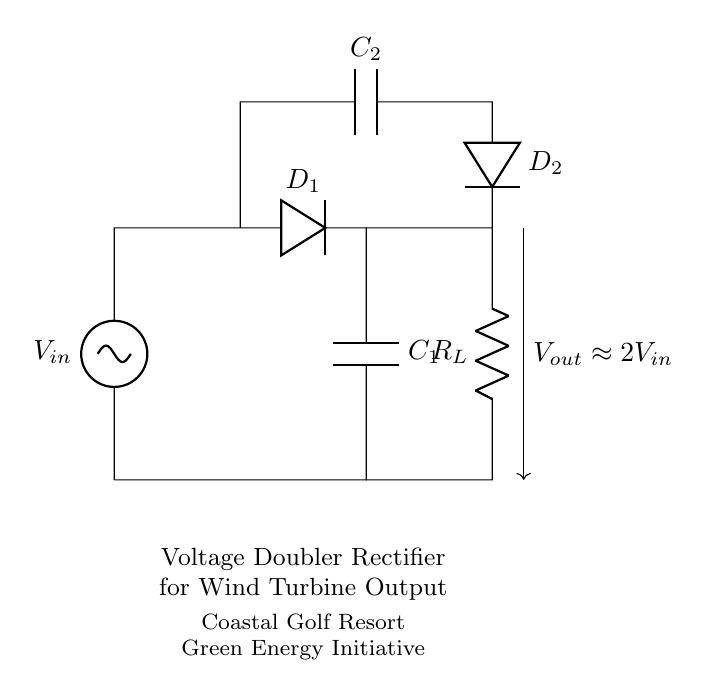What type of rectifier is shown in this circuit? The circuit shown is a voltage doubler rectifier, which is designed to produce an output voltage approximately double the input voltage. This can be identified by the arrangement of the two diodes and capacitors that work together to increase the voltage.
Answer: voltage doubler What are the main components of this circuit? The main components in the circuit are two diodes (D1 and D2), two capacitors (C1 and C2), an input voltage source (Vin), and a load resistor (R_L). These components are connected to form the voltage doubler configuration, allowing for increased output voltage.
Answer: Diodes, capacitors, voltage source, load resistor How does the output voltage relate to the input voltage? The output voltage (Vout) is approximately double the input voltage (Vin) according to the labeling on the circuit. This relationship is characteristic of a voltage doubler rectifier, which utilizes capacitors to store and combine charge to produce a higher output voltage.
Answer: approximately 2Vin What is the role of capacitor C1 in this circuit? Capacitor C1 acts as a storage element that charges when the input voltage is applied. It helps to smooth out the output voltage and contributes to the voltage doubling effect by storing energy from the input and releasing it to the load.
Answer: energy storage Which component would likely limit the current flowing through the load? The load resistor (R_L) is the component that would limit the current flowing through the load. Resistors inherently resist current flow according to Ohm's law, and their value will dictate how much current is allowed through the output of the circuit.
Answer: load resistor How many diodes are in this voltage doubler rectifier circuit? The circuit contains two diodes, D1 and D2, which are essential for the voltage doubling process by allowing current to flow in one direction and blocking it in the other, effectively doubling the voltage through their arrangement in the circuit.
Answer: two What function does diode D2 serve in this configuration? Diode D2 allows current to flow from the second capacitor C2 to the output load while preventing any backflow of current. This function is crucial for the operation of the voltage doubler as it ensures that the charge stored in C2 contributes to the output voltage while maintaining the charge stored in C1.
Answer: prevents backflow 